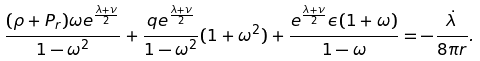Convert formula to latex. <formula><loc_0><loc_0><loc_500><loc_500>\frac { ( \rho + P _ { r } ) \omega e ^ { \frac { \lambda + \nu } { 2 } } } { 1 - \omega ^ { 2 } } + \frac { q e ^ { \frac { \lambda + \nu } { 2 } } } { 1 - \omega ^ { 2 } } ( 1 + \omega ^ { 2 } ) + \frac { e ^ { \frac { \lambda + \nu } { 2 } } \epsilon ( 1 + \omega ) } { 1 - \omega } = - \frac { \dot { \lambda } } { 8 \pi r } .</formula> 